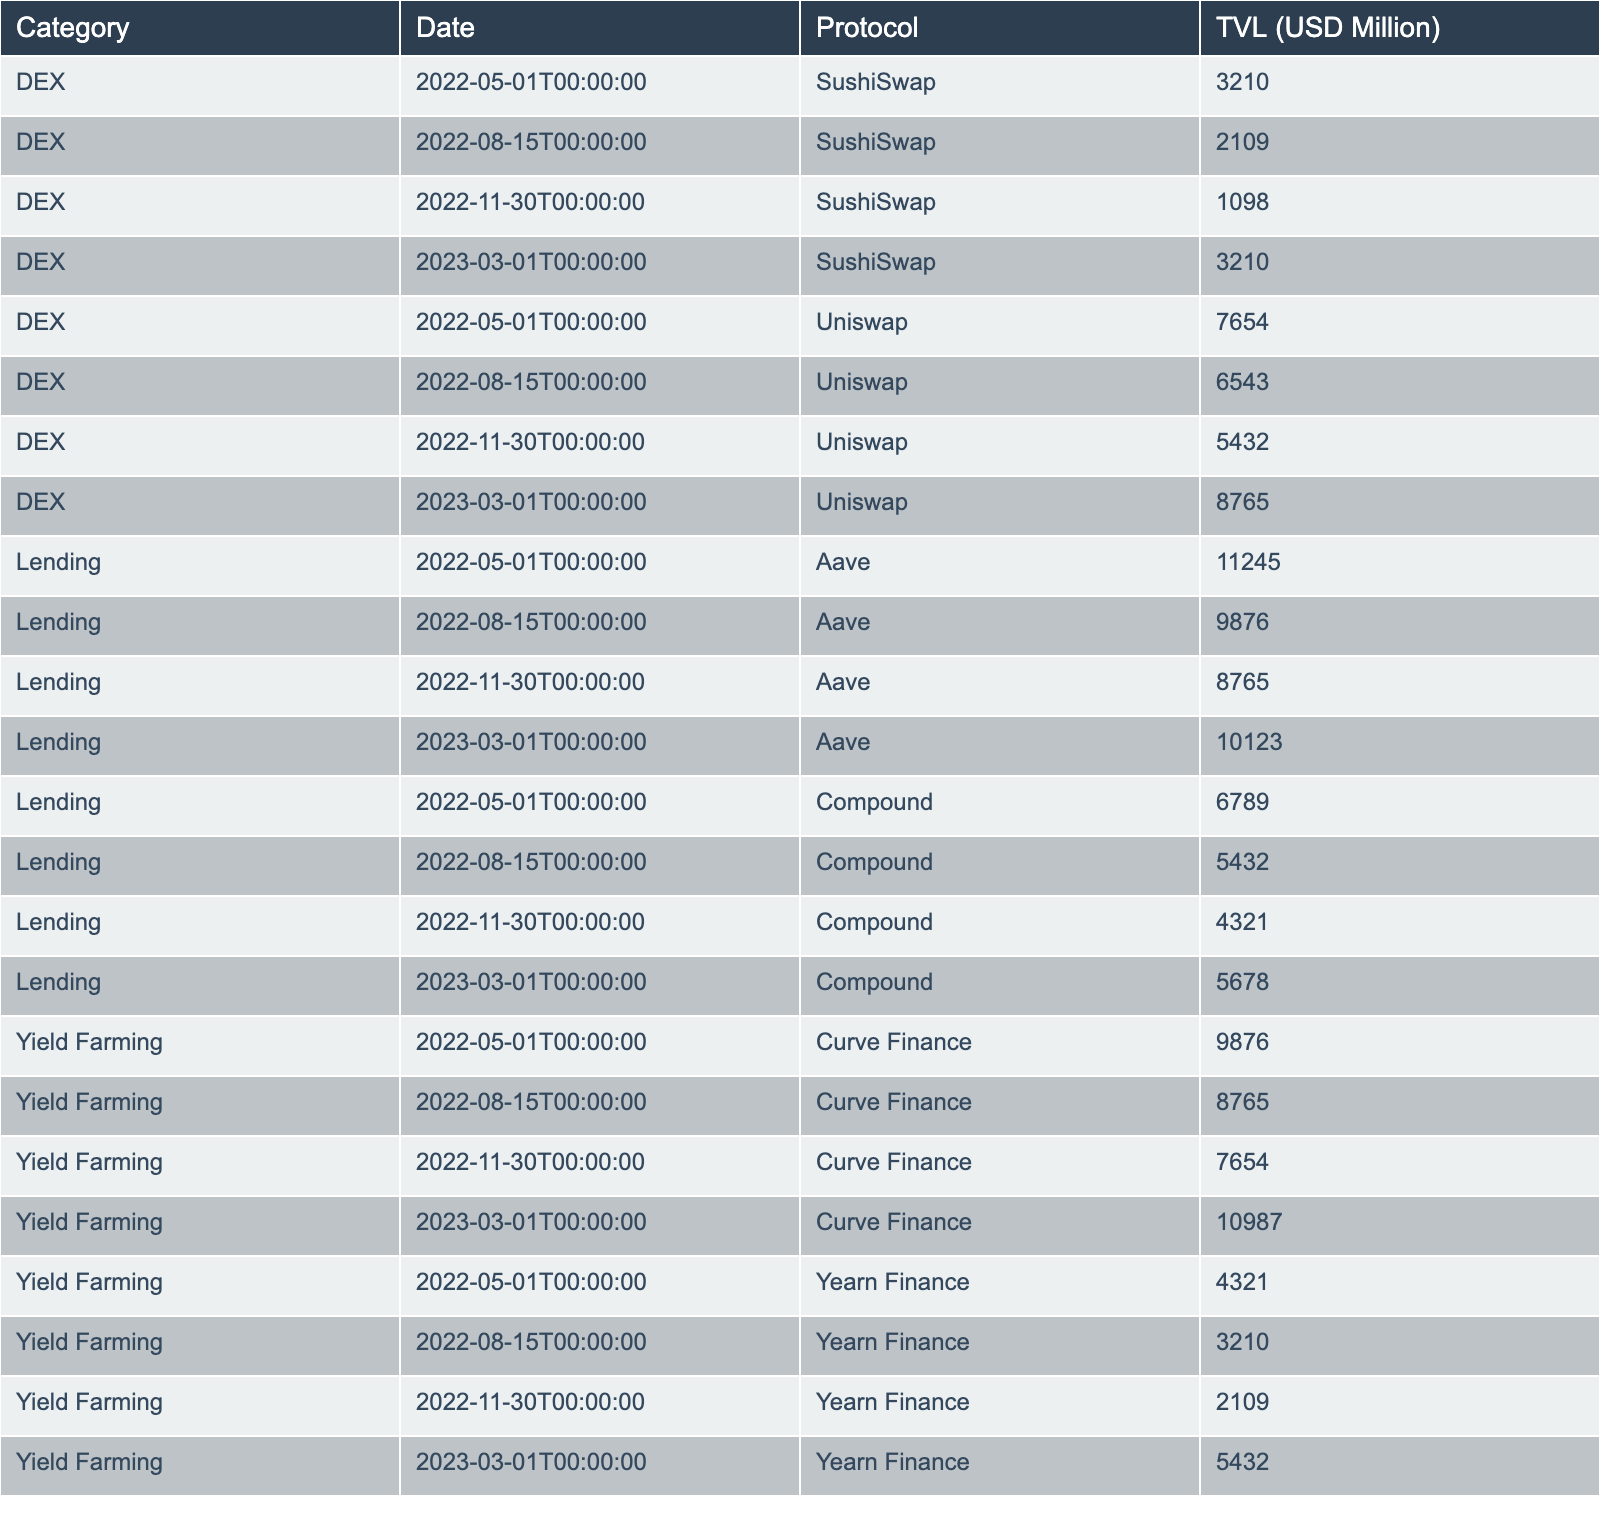What is the Total Value Locked (TVL) in Aave on March 1, 2023? By looking at the row for the Lending category, Aave, and the date of March 1, 2023, we can see that the TVL amount is 10,123 million USD.
Answer: 10,123 million USD What was the highest TVL recorded for Curve Finance in the past year? The table shows that the highest TVL for Curve Finance was on March 1, 2023, with a value of 10,987 million USD.
Answer: 10,987 million USD Calculating the total TVL for lending protocols on November 30, 2022. We add the TVL values for both Aave (8,765 million USD) and Compound (4,321 million USD) on November 30, 2022. The sum is 8,765 + 4,321 = 13,086 million USD.
Answer: 13,086 million USD What is the median TVL for Yield Farming protocols as of March 1, 2023? The TVL values for Yield Farming on March 1, 2023, are Curve Finance (10,987 million USD) and Yearn Finance (5,432 million USD). The median of these two values is the average: (10,987 + 5,432) / 2 = 8,209.5 million USD.
Answer: 8,209.5 million USD Did Uniswap ever have a higher TVL than Aave in the past year? Upon reviewing the relevant rows for both protocols, Uniswap had a TVL of 7,654 million USD on May 1, 2022, which was lower than Aave's 11,245 million USD on the same date. Since then, Aave's TVL has always been higher than Uniswap's for the recorded dates.
Answer: No Which protocol had the lowest TVL recorded in the table across all categories? Looking through the table, the lowest recorded TVL is for SushiSwap on November 30, 2022, with a value of 1,098 million USD.
Answer: 1,098 million USD What is the total TVL for all the DEXs listed over the last year as of March 1, 2023? The DEXs listed are Uniswap and SushiSwap for several dates. We sum the TVL values: (7,654 + 3,210) + (6,543 + 2,109) + (5,432 + 1,098) + (8,765 + 3,210) = 37,261 million USD.
Answer: 37,261 million USD Was there any instance when Compound had a TVL of less than 5,500 million USD? When checking the table, Compound's TVL values of 6,789 million USD and 5,678 million USD indicate that it stayed above 5,500 million USD in the recorded dates, confirming no instances below this amount.
Answer: No Which category showed the most significant increase in TVL from May 1, 2022, to March 1, 2023? Looking at the data, Yield Farming shows an increase from 9,876 million USD on May 1, 2022, to 10,987 million USD on March 1, 2023, an increase of 1,111 million USD, which is greater than the changes in the other categories.
Answer: Yield Farming What was the change in TVL for the lending protocols from August 15, 2022, to March 1, 2023? By examining Aave and Compound's values on August 15 (Aave: 9,876 million USD, Compound: 5,432 million USD) and comparing to March 1, 2023 (Aave: 10,123 million USD, Compound: 5,678 million USD), the overall change is: (10,123 + 5,678) - (9,876 + 5,432) = 1,593 million USD increase.
Answer: 1,593 million USD What is the total TVL for all protocols on August 15, 2022? This requires summing values for lending (Aave: 9,876 + Compound: 5,432), DEXs (Uniswap: 6,543 + SushiSwap: 2,109), and Yield Farming (Curve: 8,765 + Yearn: 3,210). The total is 9,876 + 5,432 + 6,543 + 2,109 + 8,765 + 3,210 = 35,935 million USD.
Answer: 35,935 million USD 